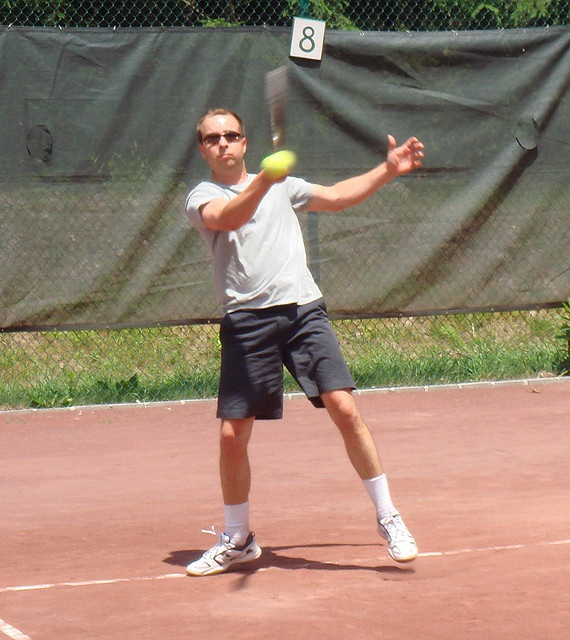Describe the objects in this image and their specific colors. I can see people in black, white, gray, and brown tones, tennis racket in black and gray tones, and sports ball in black, khaki, tan, and olive tones in this image. 